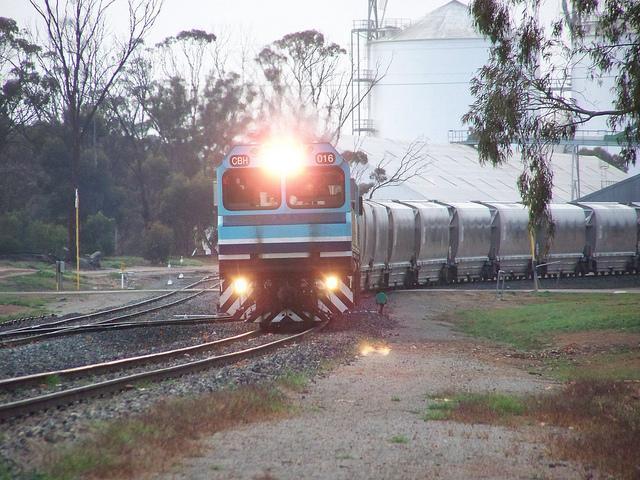How many lights are there?
Give a very brief answer. 3. How many people are in tan shorts?
Give a very brief answer. 0. 